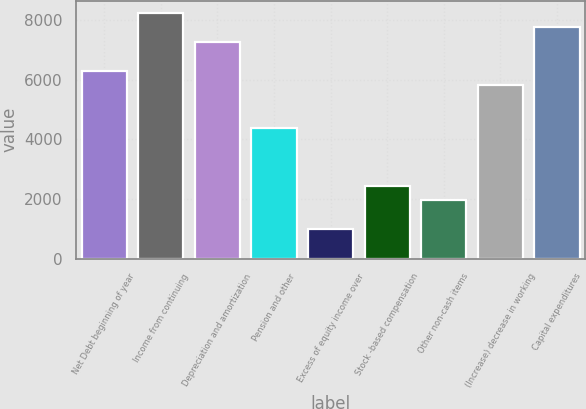<chart> <loc_0><loc_0><loc_500><loc_500><bar_chart><fcel>Net Debt beginning of year<fcel>Income from continuing<fcel>Depreciation and amortization<fcel>Pension and other<fcel>Excess of equity income over<fcel>Stock -based compensation<fcel>Other non-cash items<fcel>(Increase) decrease in working<fcel>Capital expenditures<nl><fcel>6298.4<fcel>8229.6<fcel>7264<fcel>4367.2<fcel>987.6<fcel>2436<fcel>1953.2<fcel>5815.6<fcel>7746.8<nl></chart> 